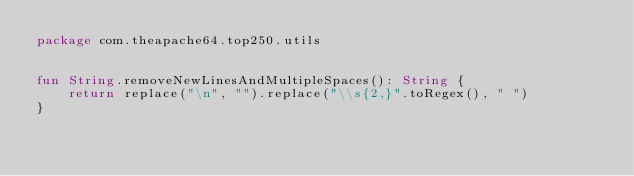<code> <loc_0><loc_0><loc_500><loc_500><_Kotlin_>package com.theapache64.top250.utils


fun String.removeNewLinesAndMultipleSpaces(): String {
    return replace("\n", "").replace("\\s{2,}".toRegex(), " ")
}
</code> 